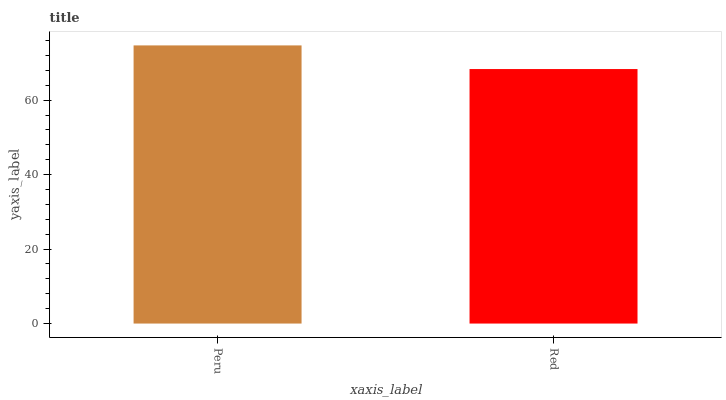Is Red the minimum?
Answer yes or no. Yes. Is Peru the maximum?
Answer yes or no. Yes. Is Red the maximum?
Answer yes or no. No. Is Peru greater than Red?
Answer yes or no. Yes. Is Red less than Peru?
Answer yes or no. Yes. Is Red greater than Peru?
Answer yes or no. No. Is Peru less than Red?
Answer yes or no. No. Is Peru the high median?
Answer yes or no. Yes. Is Red the low median?
Answer yes or no. Yes. Is Red the high median?
Answer yes or no. No. Is Peru the low median?
Answer yes or no. No. 